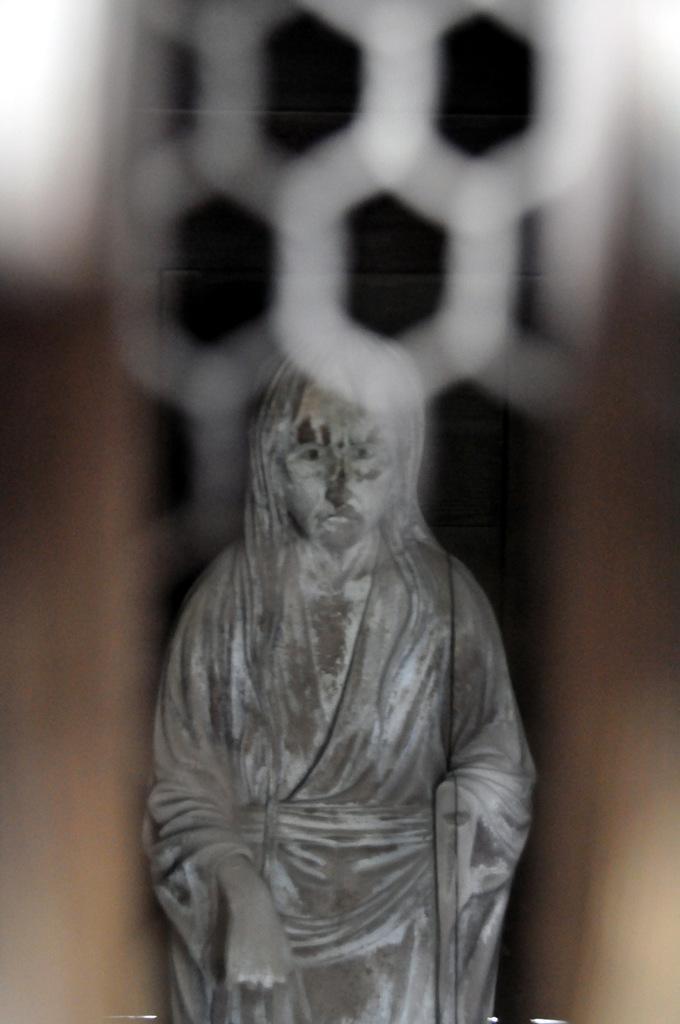How would you summarize this image in a sentence or two? In this picture I can see a statue of a person , and there is blur background. 